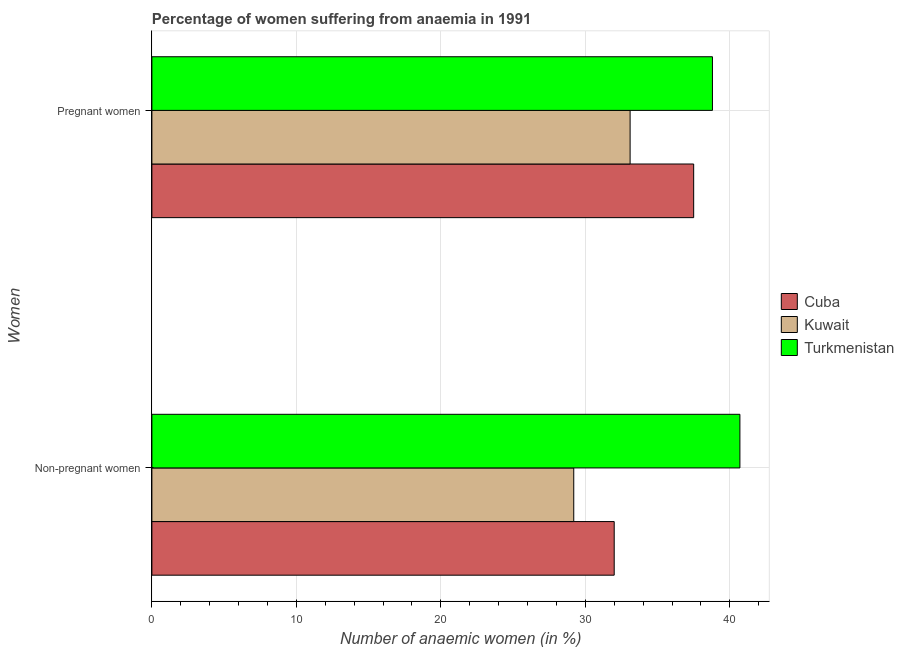How many different coloured bars are there?
Your answer should be compact. 3. Are the number of bars per tick equal to the number of legend labels?
Your answer should be very brief. Yes. Are the number of bars on each tick of the Y-axis equal?
Give a very brief answer. Yes. How many bars are there on the 1st tick from the top?
Your response must be concise. 3. How many bars are there on the 1st tick from the bottom?
Keep it short and to the point. 3. What is the label of the 2nd group of bars from the top?
Make the answer very short. Non-pregnant women. What is the percentage of pregnant anaemic women in Cuba?
Your answer should be very brief. 37.5. Across all countries, what is the maximum percentage of pregnant anaemic women?
Give a very brief answer. 38.8. Across all countries, what is the minimum percentage of non-pregnant anaemic women?
Provide a short and direct response. 29.2. In which country was the percentage of pregnant anaemic women maximum?
Ensure brevity in your answer.  Turkmenistan. In which country was the percentage of non-pregnant anaemic women minimum?
Offer a terse response. Kuwait. What is the total percentage of non-pregnant anaemic women in the graph?
Give a very brief answer. 101.9. What is the difference between the percentage of non-pregnant anaemic women in Cuba and that in Kuwait?
Your answer should be very brief. 2.8. What is the difference between the percentage of pregnant anaemic women in Cuba and the percentage of non-pregnant anaemic women in Kuwait?
Make the answer very short. 8.3. What is the average percentage of pregnant anaemic women per country?
Your answer should be compact. 36.47. What is the difference between the percentage of pregnant anaemic women and percentage of non-pregnant anaemic women in Kuwait?
Ensure brevity in your answer.  3.9. What is the ratio of the percentage of pregnant anaemic women in Kuwait to that in Cuba?
Provide a succinct answer. 0.88. Is the percentage of pregnant anaemic women in Kuwait less than that in Turkmenistan?
Give a very brief answer. Yes. In how many countries, is the percentage of non-pregnant anaemic women greater than the average percentage of non-pregnant anaemic women taken over all countries?
Your answer should be compact. 1. What does the 1st bar from the top in Pregnant women represents?
Your answer should be compact. Turkmenistan. What does the 1st bar from the bottom in Pregnant women represents?
Your answer should be compact. Cuba. Are all the bars in the graph horizontal?
Offer a very short reply. Yes. What is the difference between two consecutive major ticks on the X-axis?
Offer a terse response. 10. Does the graph contain grids?
Your answer should be compact. Yes. Where does the legend appear in the graph?
Ensure brevity in your answer.  Center right. How are the legend labels stacked?
Make the answer very short. Vertical. What is the title of the graph?
Offer a very short reply. Percentage of women suffering from anaemia in 1991. What is the label or title of the X-axis?
Your response must be concise. Number of anaemic women (in %). What is the label or title of the Y-axis?
Keep it short and to the point. Women. What is the Number of anaemic women (in %) of Cuba in Non-pregnant women?
Your answer should be very brief. 32. What is the Number of anaemic women (in %) in Kuwait in Non-pregnant women?
Give a very brief answer. 29.2. What is the Number of anaemic women (in %) of Turkmenistan in Non-pregnant women?
Your answer should be compact. 40.7. What is the Number of anaemic women (in %) in Cuba in Pregnant women?
Give a very brief answer. 37.5. What is the Number of anaemic women (in %) of Kuwait in Pregnant women?
Your response must be concise. 33.1. What is the Number of anaemic women (in %) in Turkmenistan in Pregnant women?
Keep it short and to the point. 38.8. Across all Women, what is the maximum Number of anaemic women (in %) of Cuba?
Ensure brevity in your answer.  37.5. Across all Women, what is the maximum Number of anaemic women (in %) of Kuwait?
Make the answer very short. 33.1. Across all Women, what is the maximum Number of anaemic women (in %) of Turkmenistan?
Your answer should be very brief. 40.7. Across all Women, what is the minimum Number of anaemic women (in %) in Kuwait?
Your answer should be very brief. 29.2. Across all Women, what is the minimum Number of anaemic women (in %) in Turkmenistan?
Ensure brevity in your answer.  38.8. What is the total Number of anaemic women (in %) in Cuba in the graph?
Provide a succinct answer. 69.5. What is the total Number of anaemic women (in %) in Kuwait in the graph?
Offer a very short reply. 62.3. What is the total Number of anaemic women (in %) in Turkmenistan in the graph?
Offer a terse response. 79.5. What is the difference between the Number of anaemic women (in %) in Kuwait in Non-pregnant women and that in Pregnant women?
Ensure brevity in your answer.  -3.9. What is the difference between the Number of anaemic women (in %) in Cuba in Non-pregnant women and the Number of anaemic women (in %) in Turkmenistan in Pregnant women?
Provide a short and direct response. -6.8. What is the average Number of anaemic women (in %) in Cuba per Women?
Your answer should be very brief. 34.75. What is the average Number of anaemic women (in %) in Kuwait per Women?
Your answer should be compact. 31.15. What is the average Number of anaemic women (in %) in Turkmenistan per Women?
Give a very brief answer. 39.75. What is the difference between the Number of anaemic women (in %) in Cuba and Number of anaemic women (in %) in Kuwait in Non-pregnant women?
Your response must be concise. 2.8. What is the difference between the Number of anaemic women (in %) of Cuba and Number of anaemic women (in %) of Turkmenistan in Non-pregnant women?
Offer a terse response. -8.7. What is the difference between the Number of anaemic women (in %) of Kuwait and Number of anaemic women (in %) of Turkmenistan in Non-pregnant women?
Make the answer very short. -11.5. What is the difference between the Number of anaemic women (in %) of Cuba and Number of anaemic women (in %) of Kuwait in Pregnant women?
Ensure brevity in your answer.  4.4. What is the difference between the Number of anaemic women (in %) in Kuwait and Number of anaemic women (in %) in Turkmenistan in Pregnant women?
Make the answer very short. -5.7. What is the ratio of the Number of anaemic women (in %) in Cuba in Non-pregnant women to that in Pregnant women?
Provide a short and direct response. 0.85. What is the ratio of the Number of anaemic women (in %) in Kuwait in Non-pregnant women to that in Pregnant women?
Provide a short and direct response. 0.88. What is the ratio of the Number of anaemic women (in %) of Turkmenistan in Non-pregnant women to that in Pregnant women?
Offer a terse response. 1.05. What is the difference between the highest and the second highest Number of anaemic women (in %) of Kuwait?
Ensure brevity in your answer.  3.9. What is the difference between the highest and the second highest Number of anaemic women (in %) in Turkmenistan?
Give a very brief answer. 1.9. What is the difference between the highest and the lowest Number of anaemic women (in %) in Turkmenistan?
Your answer should be compact. 1.9. 